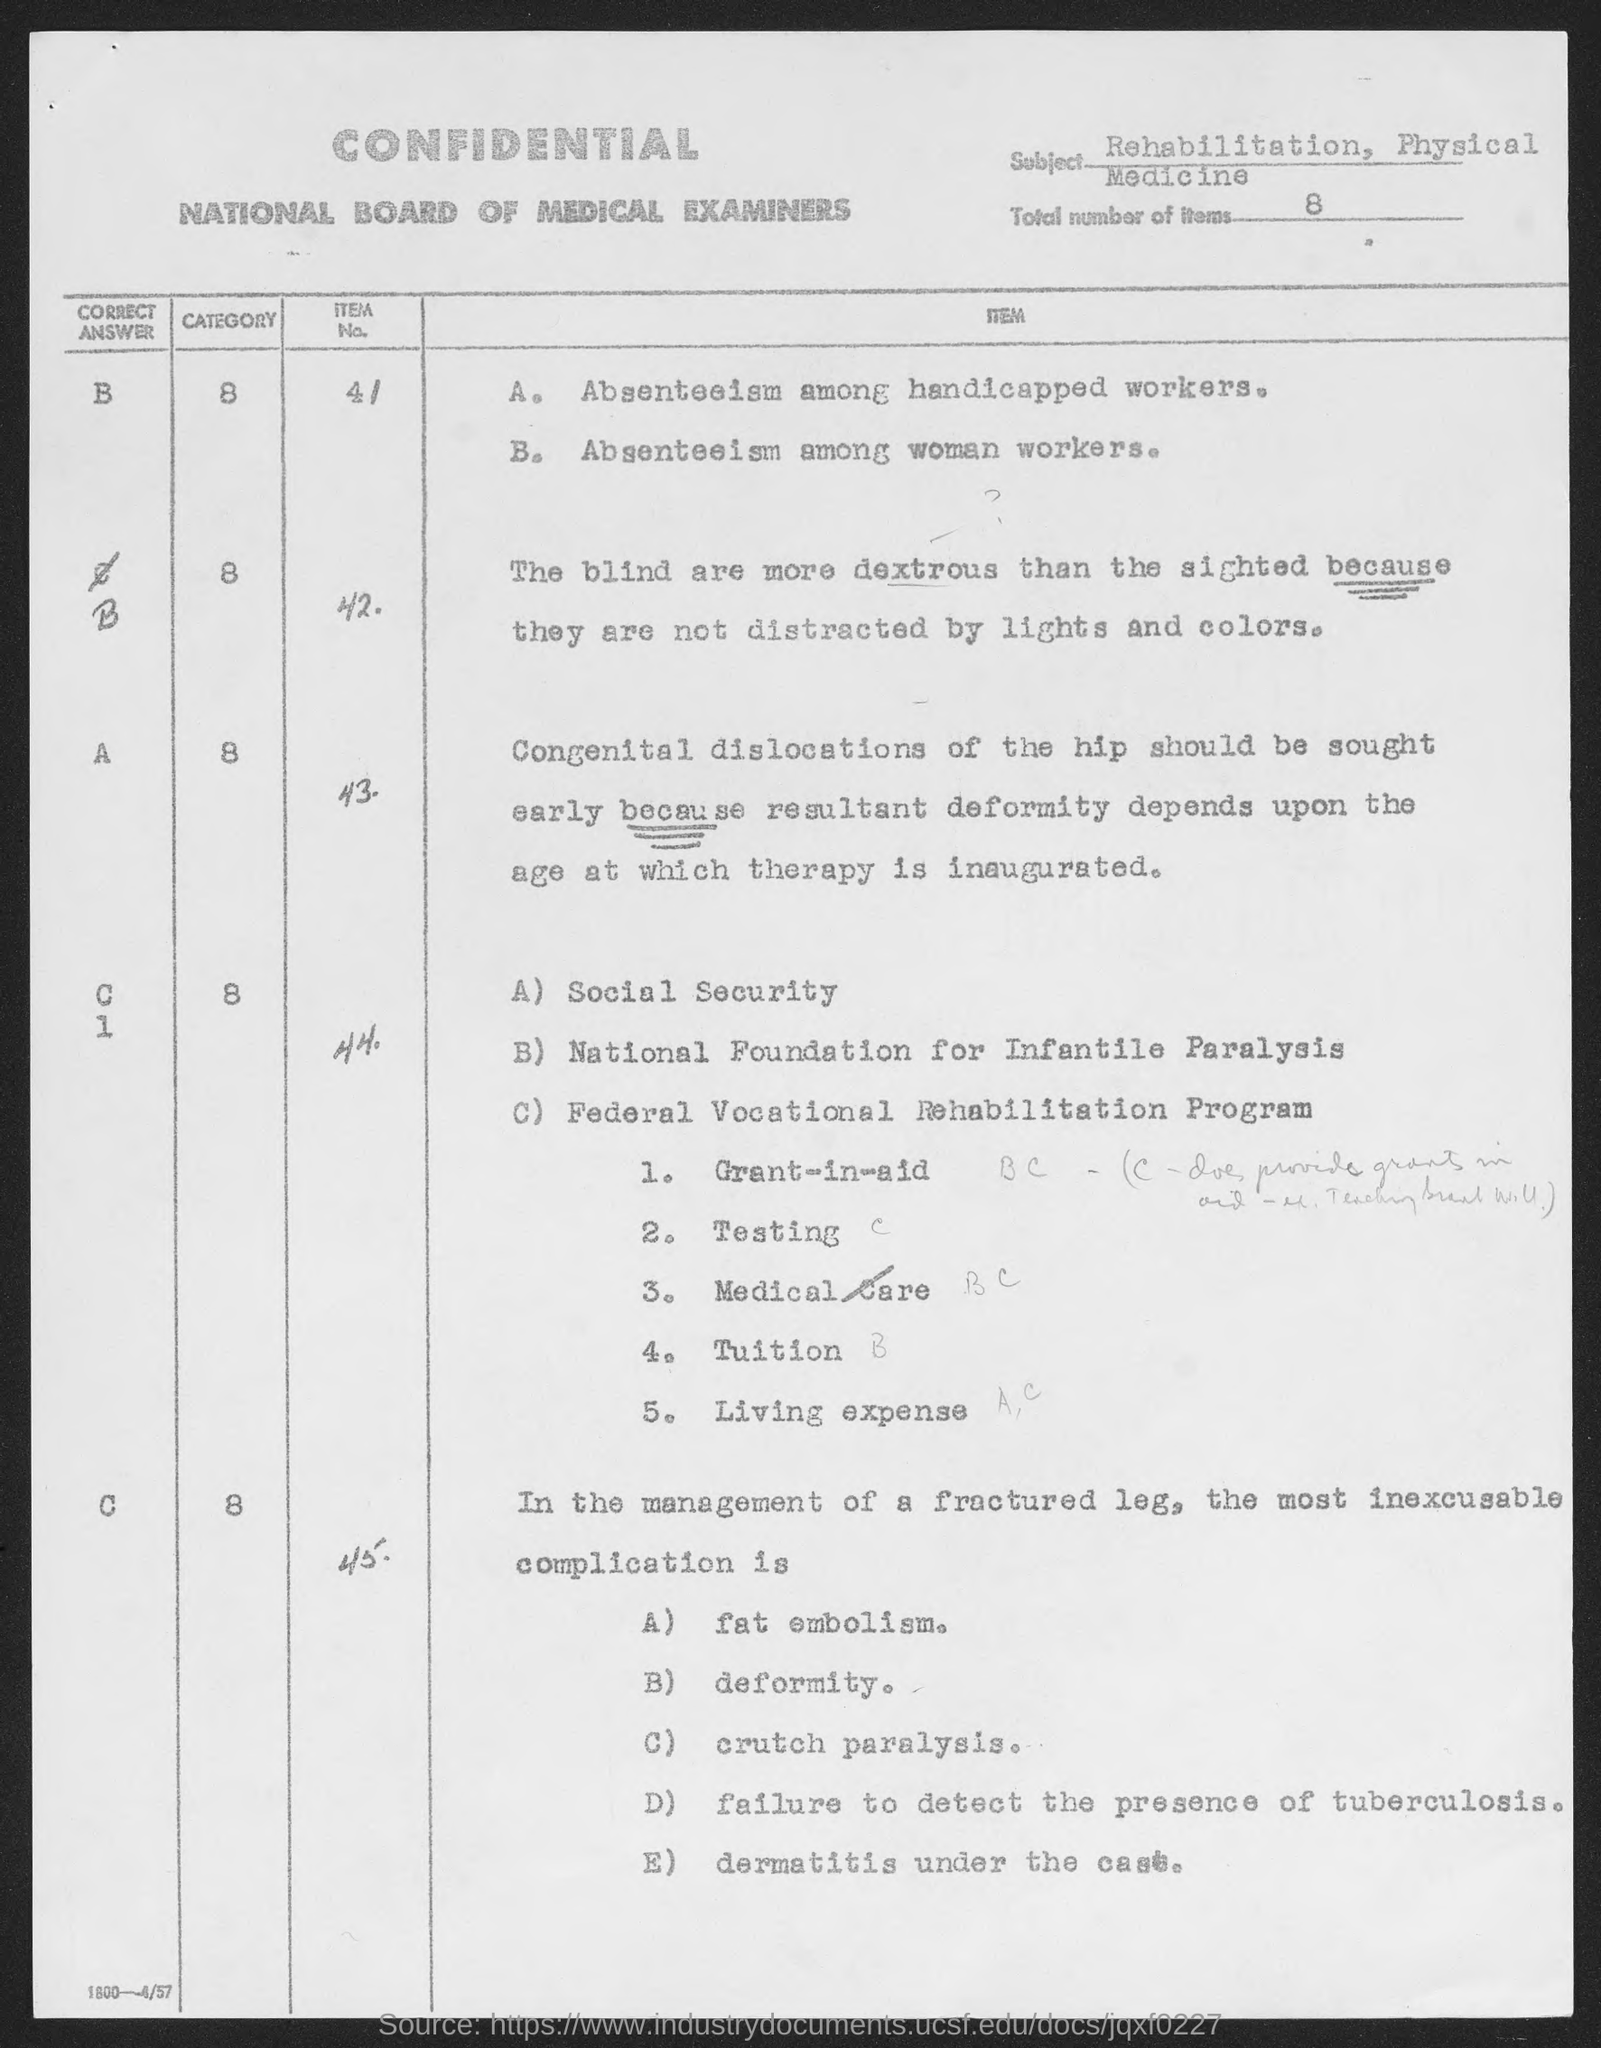What is the Subject?
Offer a very short reply. Rehabilitation, Physical Medicine. What is the Total Number of items?
Make the answer very short. 8. 